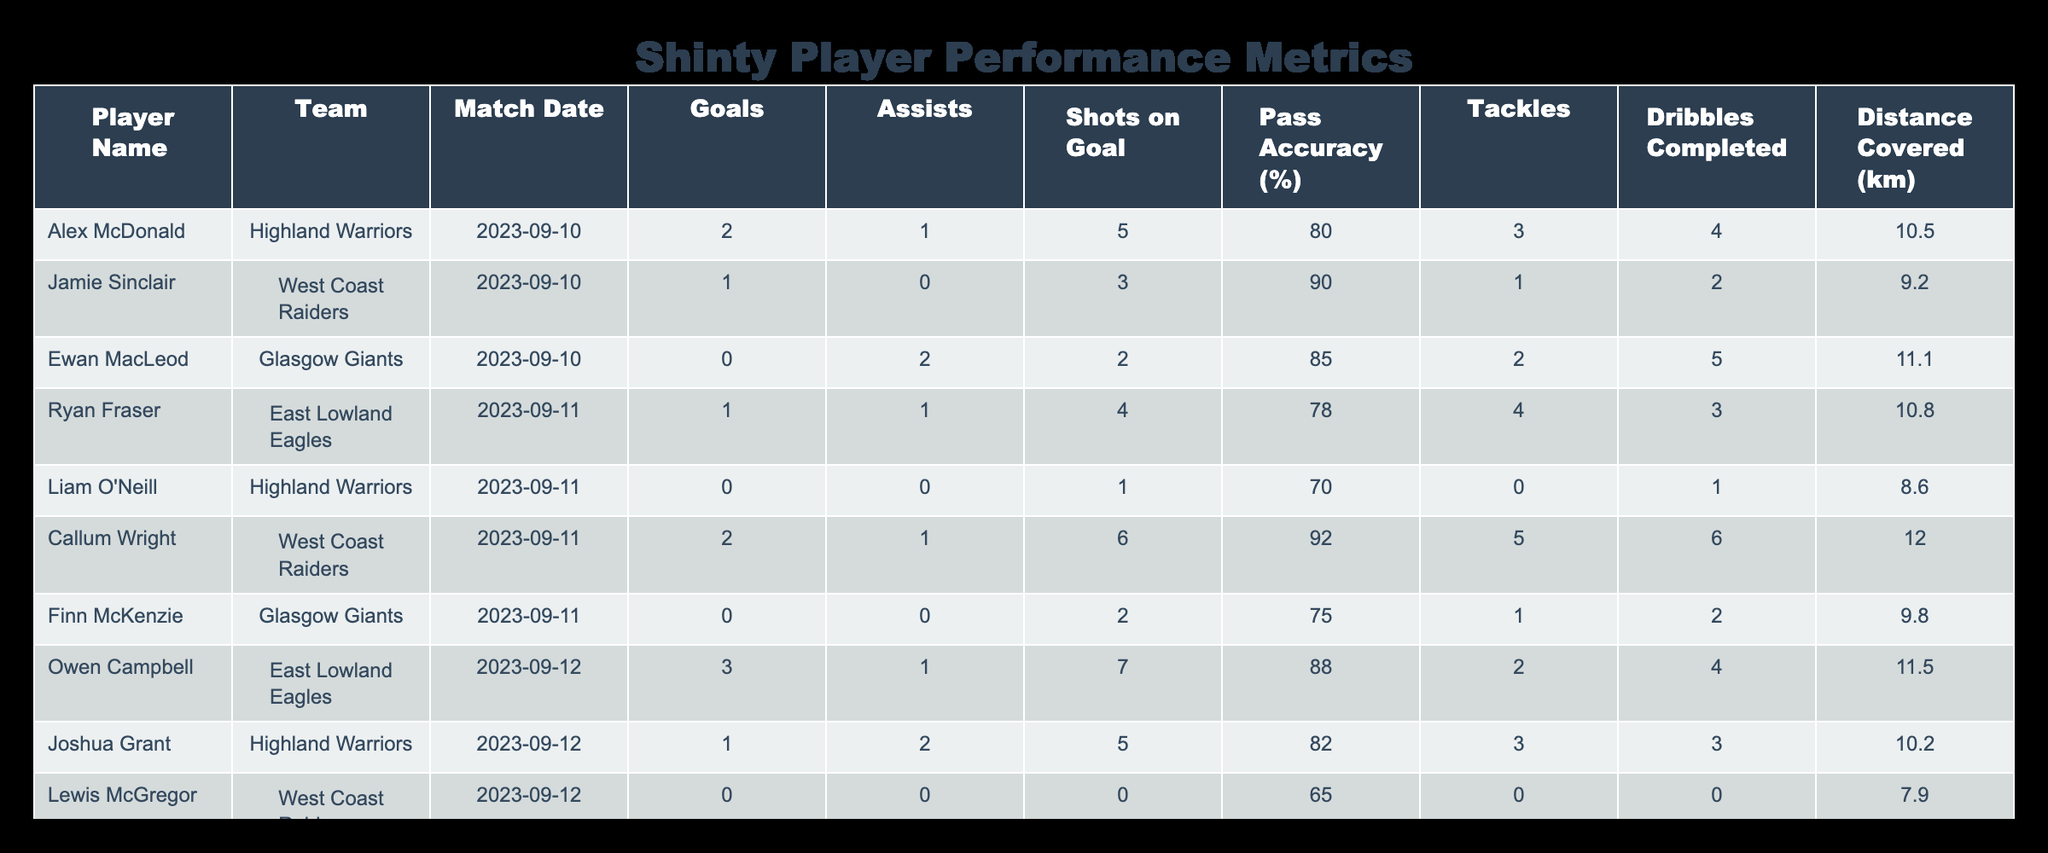What team did Ewan MacLeod play for? The table lists Ewan MacLeod under the "Team" column, which indicates he played for the Glasgow Giants.
Answer: Glasgow Giants Which player had the highest number of assists? By reviewing the "Assists" column, Owen Campbell stands out with 1 assist as the highest number seen in multiple rows; however, Ewan MacLeod and Joshua Grant each also have 2 assists, leading the group.
Answer: Ewan MacLeod and Joshua Grant What is the total number of goals scored by players from the Highland Warriors? To find this, we need to add the goals scored by the players from the Highland Warriors: Alex McDonald (2) + Liam O'Neill (0) + Joshua Grant (1) = 3 goals total.
Answer: 3 Did any player from the West Coast Raiders not score a goal? Looking at the "Goals" column for the West Coast Raiders, Lewis McGregor has a value of 0, indicating he did not score.
Answer: Yes What is the average distance covered by players from the East Lowland Eagles? The distances covered by the East Lowland Eagles players are 10.8 km (Ryan Fraser) and 11.5 km (Owen Campbell). To find the average, we sum these distances: (10.8 + 11.5) = 22.3, then divide by the number of data points, which is 2. 22.3 / 2 = 11.15 km.
Answer: 11.15 km Now, which player had the highest shot accuracy? To determine this, we check the "Pass Accuracy (%)" column, where Callum Wright scored the highest at 92%, making him the player with the best accuracy.
Answer: Callum Wright How many tackles did Ryan Fraser complete in his match? The table indicates Ryan Fraser completed 4 tackles, as shown in the specific row under the "Tackles" column.
Answer: 4 Which player had the most shots on goal? From the "Shots on Goal" column, we see that Owen Campbell had the highest count with 7 shots in the match, outpacing his teammates.
Answer: Owen Campbell 